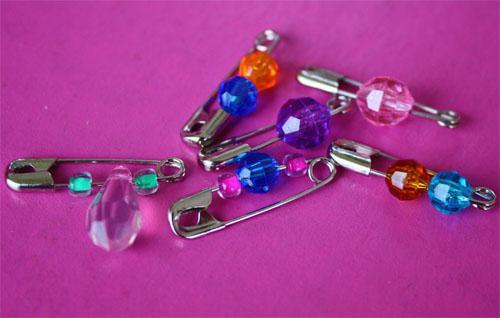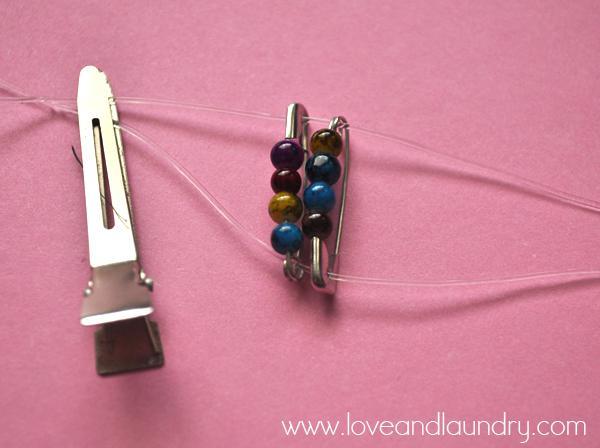The first image is the image on the left, the second image is the image on the right. Given the left and right images, does the statement "An image shows exactly six safety pins strung with beads, displayed on purple." hold true? Answer yes or no. Yes. The first image is the image on the left, the second image is the image on the right. Given the left and right images, does the statement "The left image has four safety pins." hold true? Answer yes or no. No. 